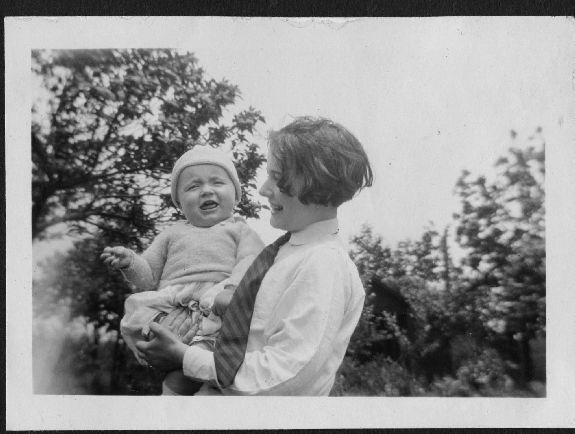How many kids are sitting?
Give a very brief answer. 1. How many people in this photo are wearing hats?
Give a very brief answer. 1. How many people are in the photo?
Give a very brief answer. 2. 